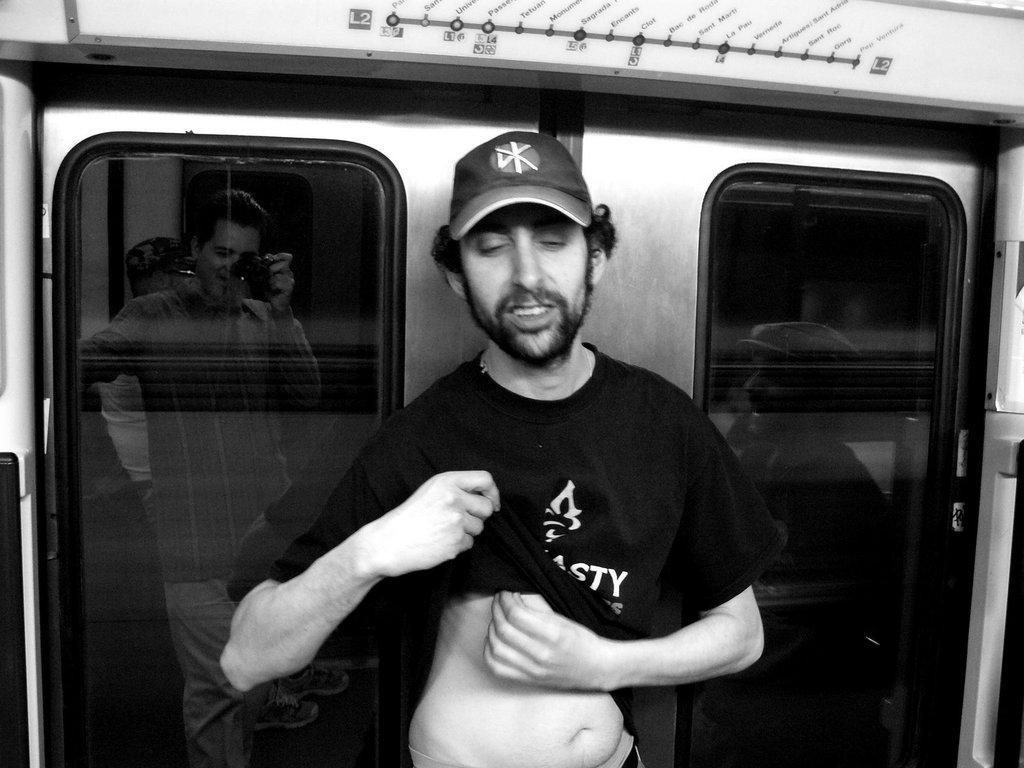Can you describe this image briefly? There is a person standing and wearing cap. In the back we can see glasses. On that we can see reflections of persons. One person is holding a camera. 